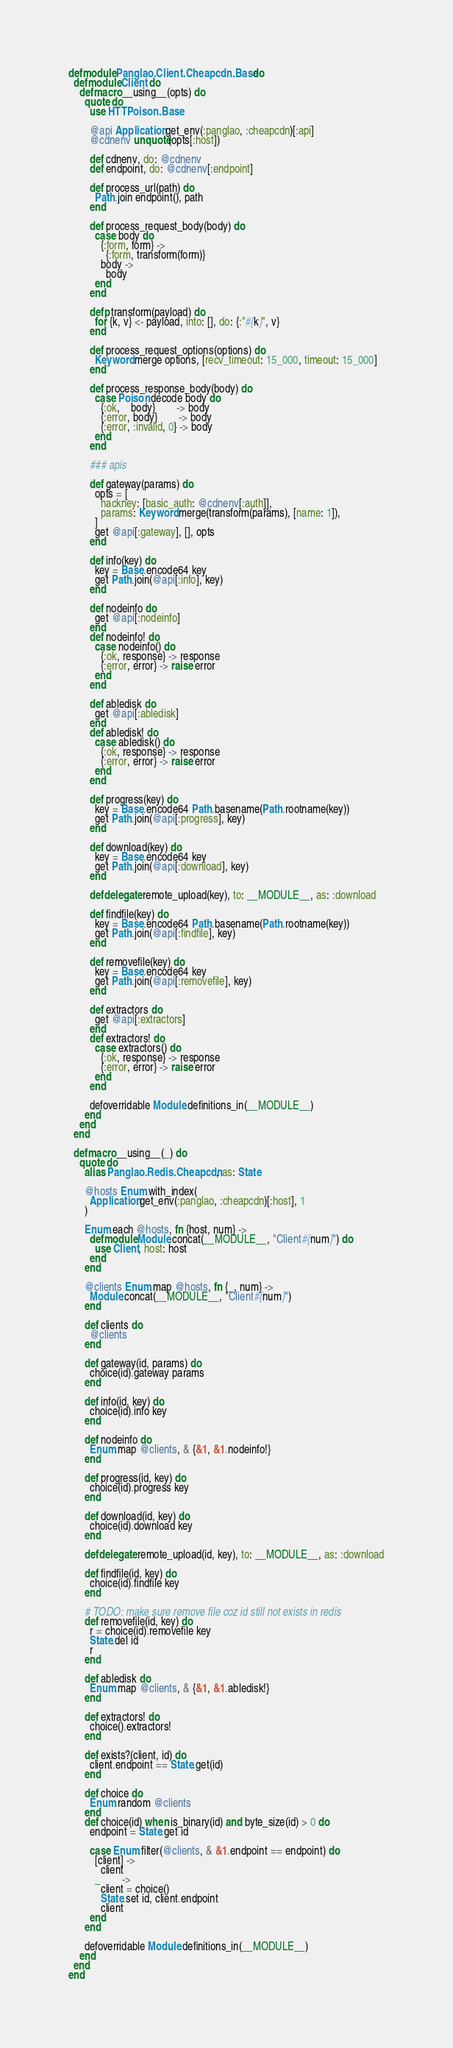<code> <loc_0><loc_0><loc_500><loc_500><_Elixir_>defmodule Panglao.Client.Cheapcdn.Base do
  defmodule Client do
    defmacro __using__(opts) do
      quote do
        use HTTPoison.Base

        @api Application.get_env(:panglao, :cheapcdn)[:api]
        @cdnenv unquote(opts[:host])

        def cdnenv, do: @cdnenv
        def endpoint, do: @cdnenv[:endpoint]

        def process_url(path) do
          Path.join endpoint(), path
        end

        def process_request_body(body) do
          case body do
            {:form, form} ->
              {:form, transform(form)}
            body ->
              body
          end
        end

        defp transform(payload) do
          for {k, v} <- payload, into: [], do: {:"#{k}", v}
        end

        def process_request_options(options) do
          Keyword.merge options, [recv_timeout: 15_000, timeout: 15_000]
        end

        def process_response_body(body) do
          case Poison.decode body do
            {:ok,    body}        -> body
            {:error, body}        -> body
            {:error, :invalid, 0} -> body
          end
        end

        ### apis

        def gateway(params) do
          opts = [
            hackney: [basic_auth: @cdnenv[:auth]],
            params: Keyword.merge(transform(params), [name: 1]),
          ]
          get @api[:gateway], [], opts
        end

        def info(key) do
          key = Base.encode64 key
          get Path.join(@api[:info], key)
        end

        def nodeinfo do
          get @api[:nodeinfo]
        end
        def nodeinfo! do
          case nodeinfo() do
            {:ok, response} -> response
            {:error, error} -> raise error
          end
        end

        def abledisk do
          get @api[:abledisk]
        end
        def abledisk! do
          case abledisk() do
            {:ok, response} -> response
            {:error, error} -> raise error
          end
        end

        def progress(key) do
          key = Base.encode64 Path.basename(Path.rootname(key))
          get Path.join(@api[:progress], key)
        end

        def download(key) do
          key = Base.encode64 key
          get Path.join(@api[:download], key)
        end

        defdelegate remote_upload(key), to: __MODULE__, as: :download

        def findfile(key) do
          key = Base.encode64 Path.basename(Path.rootname(key))
          get Path.join(@api[:findfile], key)
        end

        def removefile(key) do
          key = Base.encode64 key
          get Path.join(@api[:removefile], key)
        end

        def extractors do
          get @api[:extractors]
        end
        def extractors! do
          case extractors() do
            {:ok, response} -> response
            {:error, error} -> raise error
          end
        end

        defoverridable Module.definitions_in(__MODULE__)
      end
    end
  end

  defmacro __using__(_) do
    quote do
      alias Panglao.Redis.Cheapcdn, as: State

      @hosts Enum.with_index(
        Application.get_env(:panglao, :cheapcdn)[:host], 1
      )

      Enum.each @hosts, fn {host, num} ->
        defmodule Module.concat(__MODULE__, "Client#{num}") do
          use Client, host: host
        end
      end

      @clients Enum.map @hosts, fn {_, num} ->
        Module.concat(__MODULE__, "Client#{num}")
      end

      def clients do
        @clients
      end

      def gateway(id, params) do
        choice(id).gateway params
      end

      def info(id, key) do
        choice(id).info key
      end

      def nodeinfo do
        Enum.map @clients, & {&1, &1.nodeinfo!}
      end

      def progress(id, key) do
        choice(id).progress key
      end

      def download(id, key) do
        choice(id).download key
      end

      defdelegate remote_upload(id, key), to: __MODULE__, as: :download

      def findfile(id, key) do
        choice(id).findfile key
      end

      # TODO: make sure remove file coz id still not exists in redis
      def removefile(id, key) do
        r = choice(id).removefile key
        State.del id
        r
      end

      def abledisk do
        Enum.map @clients, & {&1, &1.abledisk!}
      end

      def extractors! do
        choice().extractors!
      end

      def exists?(client, id) do
        client.endpoint == State.get(id)
      end

      def choice do
        Enum.random @clients
      end
      def choice(id) when is_binary(id) and byte_size(id) > 0 do
        endpoint = State.get id

        case Enum.filter(@clients, & &1.endpoint == endpoint) do
          [client] ->
            client
          _        ->
            client = choice()
            State.set id, client.endpoint
            client
        end
      end

      defoverridable Module.definitions_in(__MODULE__)
    end
  end
end
</code> 